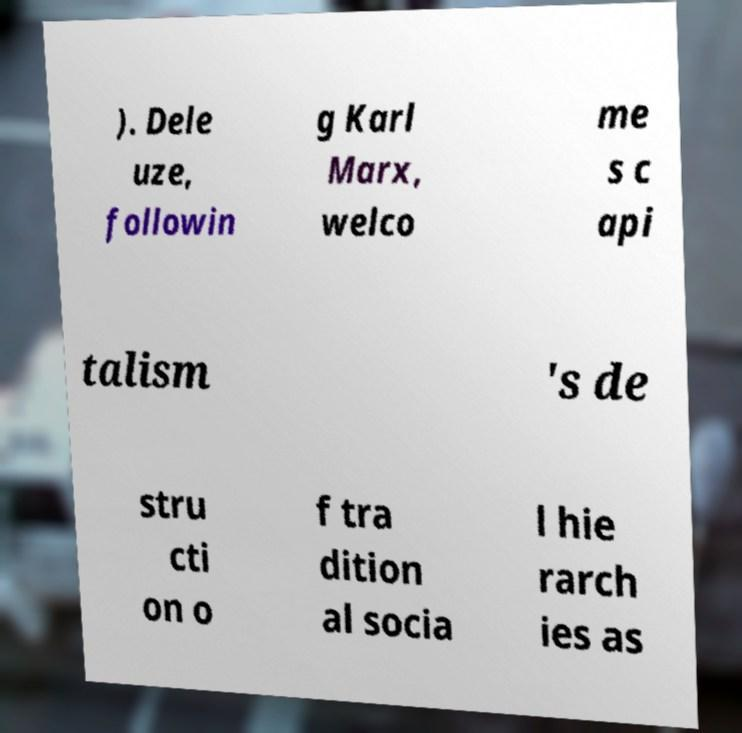Could you assist in decoding the text presented in this image and type it out clearly? ). Dele uze, followin g Karl Marx, welco me s c api talism 's de stru cti on o f tra dition al socia l hie rarch ies as 